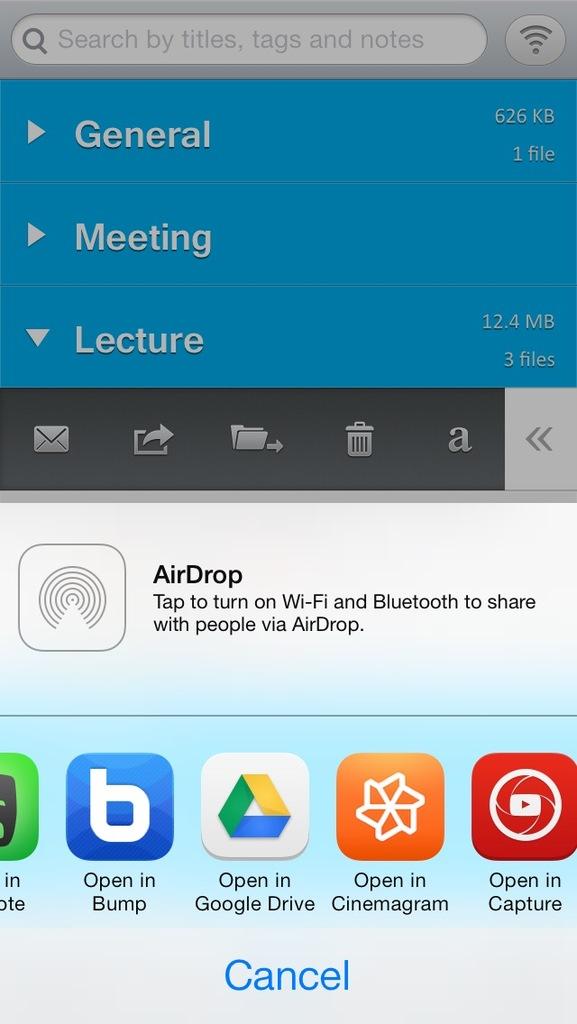What is the blue icon?
Your answer should be very brief. Open in bump. How much space is being taken up by the "general" category?
Offer a very short reply. 626 kb. 